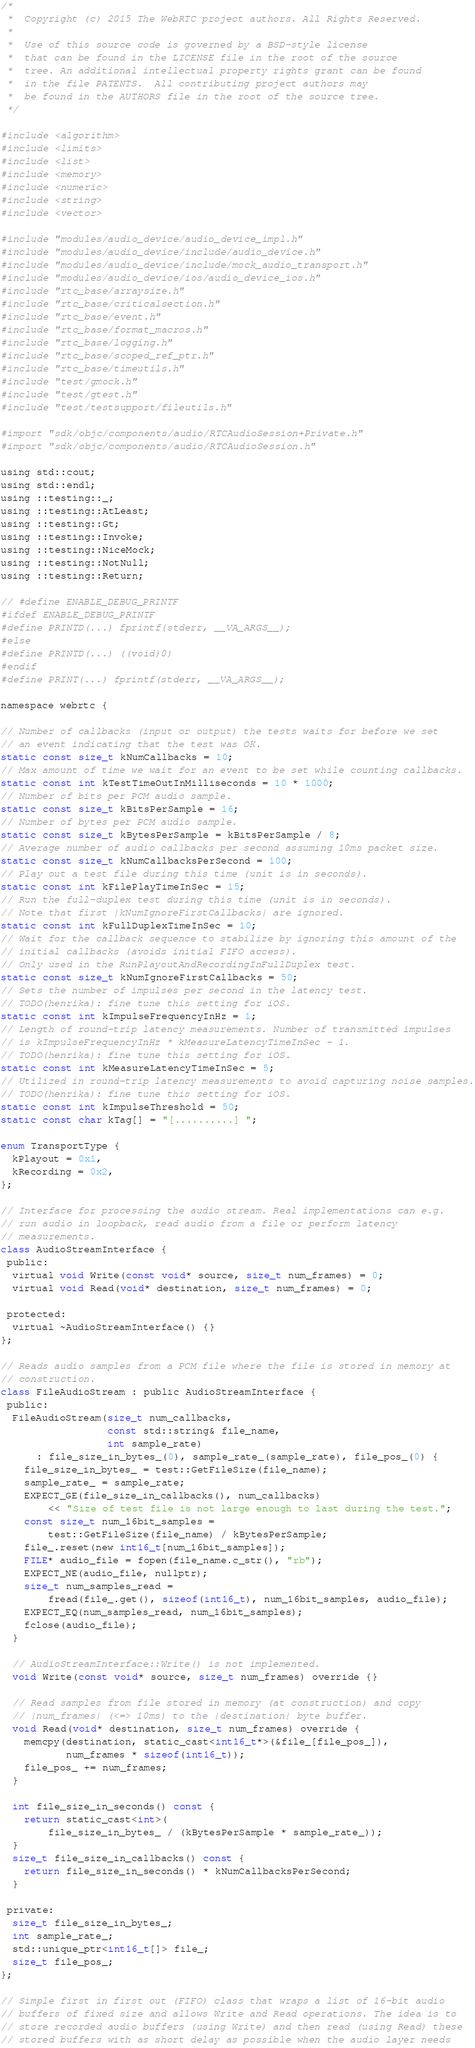Convert code to text. <code><loc_0><loc_0><loc_500><loc_500><_ObjectiveC_>/*
 *  Copyright (c) 2015 The WebRTC project authors. All Rights Reserved.
 *
 *  Use of this source code is governed by a BSD-style license
 *  that can be found in the LICENSE file in the root of the source
 *  tree. An additional intellectual property rights grant can be found
 *  in the file PATENTS.  All contributing project authors may
 *  be found in the AUTHORS file in the root of the source tree.
 */

#include <algorithm>
#include <limits>
#include <list>
#include <memory>
#include <numeric>
#include <string>
#include <vector>

#include "modules/audio_device/audio_device_impl.h"
#include "modules/audio_device/include/audio_device.h"
#include "modules/audio_device/include/mock_audio_transport.h"
#include "modules/audio_device/ios/audio_device_ios.h"
#include "rtc_base/arraysize.h"
#include "rtc_base/criticalsection.h"
#include "rtc_base/event.h"
#include "rtc_base/format_macros.h"
#include "rtc_base/logging.h"
#include "rtc_base/scoped_ref_ptr.h"
#include "rtc_base/timeutils.h"
#include "test/gmock.h"
#include "test/gtest.h"
#include "test/testsupport/fileutils.h"

#import "sdk/objc/components/audio/RTCAudioSession+Private.h"
#import "sdk/objc/components/audio/RTCAudioSession.h"

using std::cout;
using std::endl;
using ::testing::_;
using ::testing::AtLeast;
using ::testing::Gt;
using ::testing::Invoke;
using ::testing::NiceMock;
using ::testing::NotNull;
using ::testing::Return;

// #define ENABLE_DEBUG_PRINTF
#ifdef ENABLE_DEBUG_PRINTF
#define PRINTD(...) fprintf(stderr, __VA_ARGS__);
#else
#define PRINTD(...) ((void)0)
#endif
#define PRINT(...) fprintf(stderr, __VA_ARGS__);

namespace webrtc {

// Number of callbacks (input or output) the tests waits for before we set
// an event indicating that the test was OK.
static const size_t kNumCallbacks = 10;
// Max amount of time we wait for an event to be set while counting callbacks.
static const int kTestTimeOutInMilliseconds = 10 * 1000;
// Number of bits per PCM audio sample.
static const size_t kBitsPerSample = 16;
// Number of bytes per PCM audio sample.
static const size_t kBytesPerSample = kBitsPerSample / 8;
// Average number of audio callbacks per second assuming 10ms packet size.
static const size_t kNumCallbacksPerSecond = 100;
// Play out a test file during this time (unit is in seconds).
static const int kFilePlayTimeInSec = 15;
// Run the full-duplex test during this time (unit is in seconds).
// Note that first |kNumIgnoreFirstCallbacks| are ignored.
static const int kFullDuplexTimeInSec = 10;
// Wait for the callback sequence to stabilize by ignoring this amount of the
// initial callbacks (avoids initial FIFO access).
// Only used in the RunPlayoutAndRecordingInFullDuplex test.
static const size_t kNumIgnoreFirstCallbacks = 50;
// Sets the number of impulses per second in the latency test.
// TODO(henrika): fine tune this setting for iOS.
static const int kImpulseFrequencyInHz = 1;
// Length of round-trip latency measurements. Number of transmitted impulses
// is kImpulseFrequencyInHz * kMeasureLatencyTimeInSec - 1.
// TODO(henrika): fine tune this setting for iOS.
static const int kMeasureLatencyTimeInSec = 5;
// Utilized in round-trip latency measurements to avoid capturing noise samples.
// TODO(henrika): fine tune this setting for iOS.
static const int kImpulseThreshold = 50;
static const char kTag[] = "[..........] ";

enum TransportType {
  kPlayout = 0x1,
  kRecording = 0x2,
};

// Interface for processing the audio stream. Real implementations can e.g.
// run audio in loopback, read audio from a file or perform latency
// measurements.
class AudioStreamInterface {
 public:
  virtual void Write(const void* source, size_t num_frames) = 0;
  virtual void Read(void* destination, size_t num_frames) = 0;

 protected:
  virtual ~AudioStreamInterface() {}
};

// Reads audio samples from a PCM file where the file is stored in memory at
// construction.
class FileAudioStream : public AudioStreamInterface {
 public:
  FileAudioStream(size_t num_callbacks,
                  const std::string& file_name,
                  int sample_rate)
      : file_size_in_bytes_(0), sample_rate_(sample_rate), file_pos_(0) {
    file_size_in_bytes_ = test::GetFileSize(file_name);
    sample_rate_ = sample_rate;
    EXPECT_GE(file_size_in_callbacks(), num_callbacks)
        << "Size of test file is not large enough to last during the test.";
    const size_t num_16bit_samples =
        test::GetFileSize(file_name) / kBytesPerSample;
    file_.reset(new int16_t[num_16bit_samples]);
    FILE* audio_file = fopen(file_name.c_str(), "rb");
    EXPECT_NE(audio_file, nullptr);
    size_t num_samples_read =
        fread(file_.get(), sizeof(int16_t), num_16bit_samples, audio_file);
    EXPECT_EQ(num_samples_read, num_16bit_samples);
    fclose(audio_file);
  }

  // AudioStreamInterface::Write() is not implemented.
  void Write(const void* source, size_t num_frames) override {}

  // Read samples from file stored in memory (at construction) and copy
  // |num_frames| (<=> 10ms) to the |destination| byte buffer.
  void Read(void* destination, size_t num_frames) override {
    memcpy(destination, static_cast<int16_t*>(&file_[file_pos_]),
           num_frames * sizeof(int16_t));
    file_pos_ += num_frames;
  }

  int file_size_in_seconds() const {
    return static_cast<int>(
        file_size_in_bytes_ / (kBytesPerSample * sample_rate_));
  }
  size_t file_size_in_callbacks() const {
    return file_size_in_seconds() * kNumCallbacksPerSecond;
  }

 private:
  size_t file_size_in_bytes_;
  int sample_rate_;
  std::unique_ptr<int16_t[]> file_;
  size_t file_pos_;
};

// Simple first in first out (FIFO) class that wraps a list of 16-bit audio
// buffers of fixed size and allows Write and Read operations. The idea is to
// store recorded audio buffers (using Write) and then read (using Read) these
// stored buffers with as short delay as possible when the audio layer needs</code> 